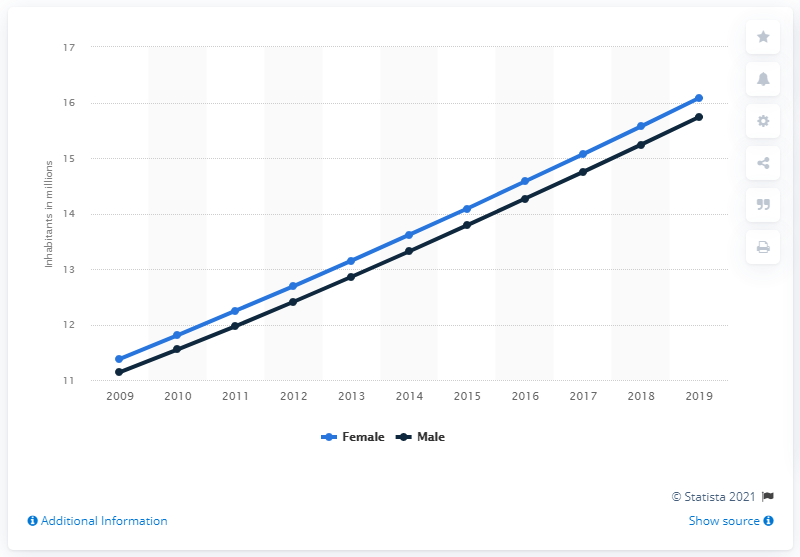Point out several critical features in this image. In 2019, the male population of Angola was 15.74 million. In 2019, the female population of Angola was estimated to be 16.08 million. 